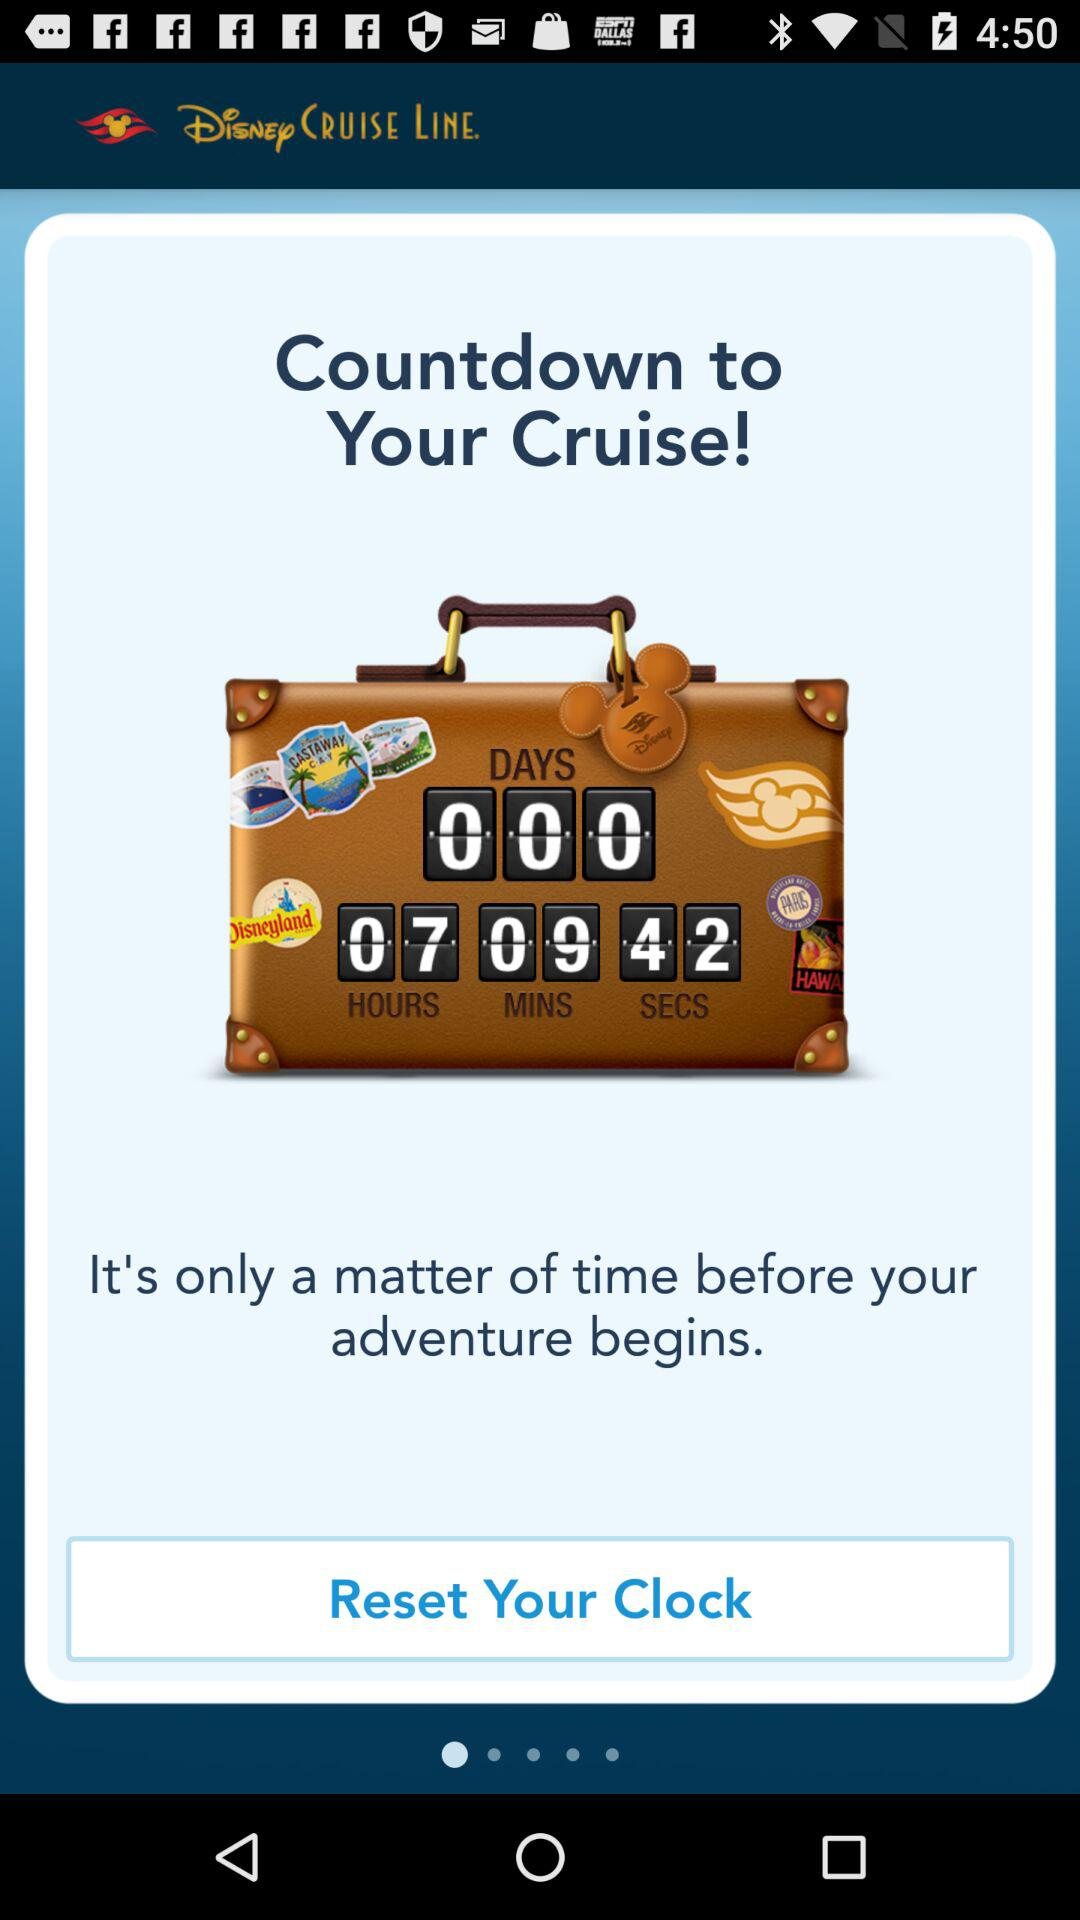How many seconds are left for the countdown to your cruise? There are 42 seconds remaining until the countdown to your enchanting Disney cruise concludes. Prepare for a magical adventure full of laughter and enjoyment! 